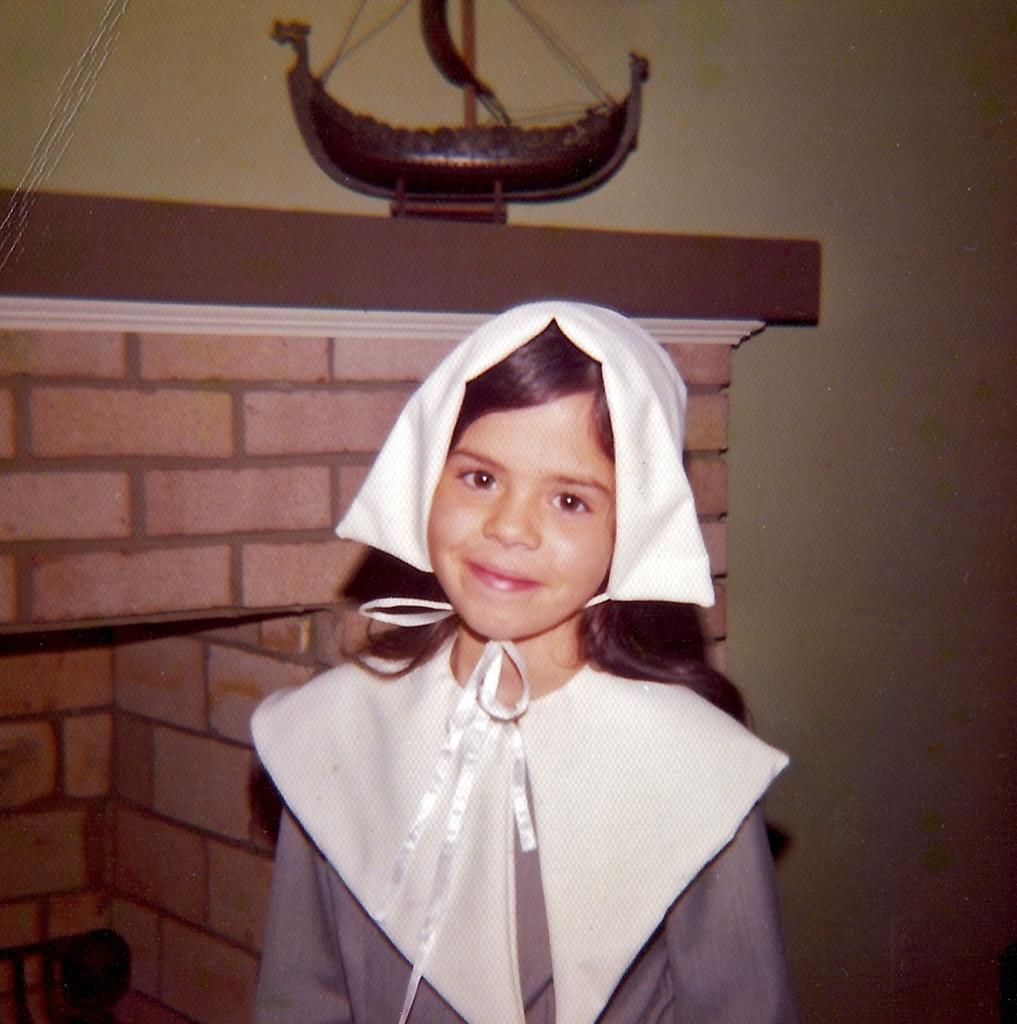How would you summarize this image in a sentence or two? This image consists of a girl. She is standing. There is a toy boat at the top. 